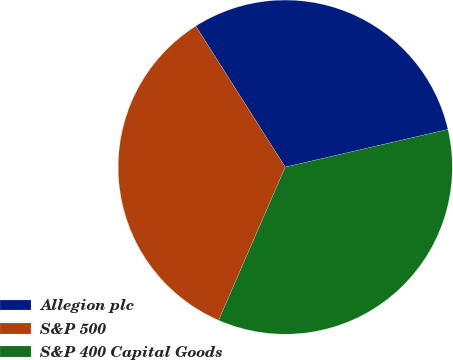<chart> <loc_0><loc_0><loc_500><loc_500><pie_chart><fcel>Allegion plc<fcel>S&P 500<fcel>S&P 400 Capital Goods<nl><fcel>30.38%<fcel>34.47%<fcel>35.15%<nl></chart> 